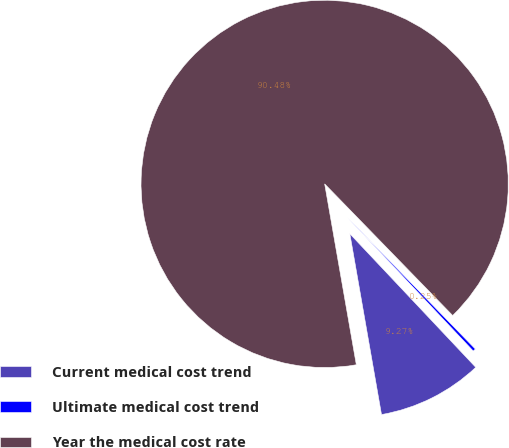Convert chart to OTSL. <chart><loc_0><loc_0><loc_500><loc_500><pie_chart><fcel>Current medical cost trend<fcel>Ultimate medical cost trend<fcel>Year the medical cost rate<nl><fcel>9.27%<fcel>0.25%<fcel>90.48%<nl></chart> 